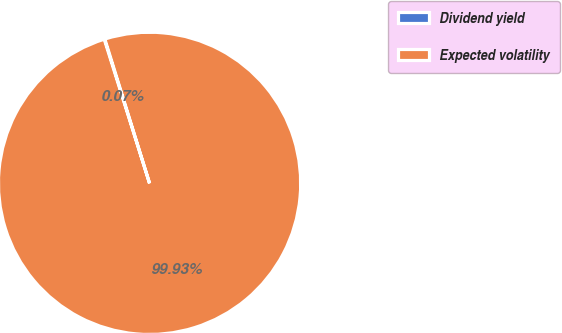Convert chart. <chart><loc_0><loc_0><loc_500><loc_500><pie_chart><fcel>Dividend yield<fcel>Expected volatility<nl><fcel>0.07%<fcel>99.93%<nl></chart> 